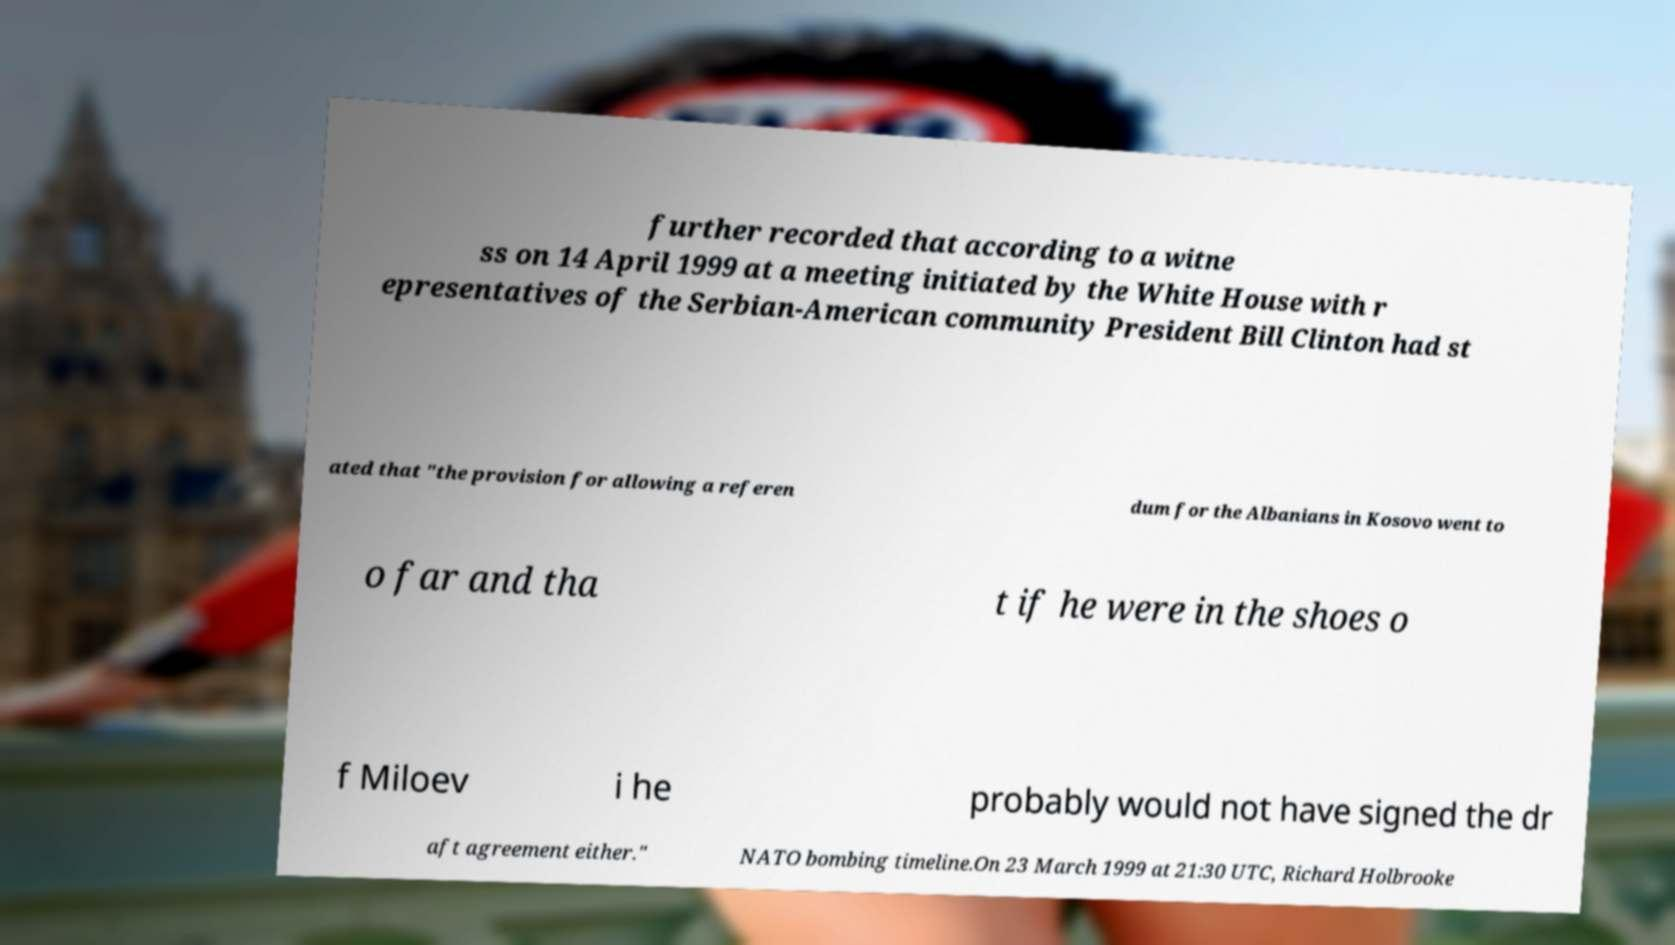Please identify and transcribe the text found in this image. further recorded that according to a witne ss on 14 April 1999 at a meeting initiated by the White House with r epresentatives of the Serbian-American community President Bill Clinton had st ated that "the provision for allowing a referen dum for the Albanians in Kosovo went to o far and tha t if he were in the shoes o f Miloev i he probably would not have signed the dr aft agreement either." NATO bombing timeline.On 23 March 1999 at 21:30 UTC, Richard Holbrooke 